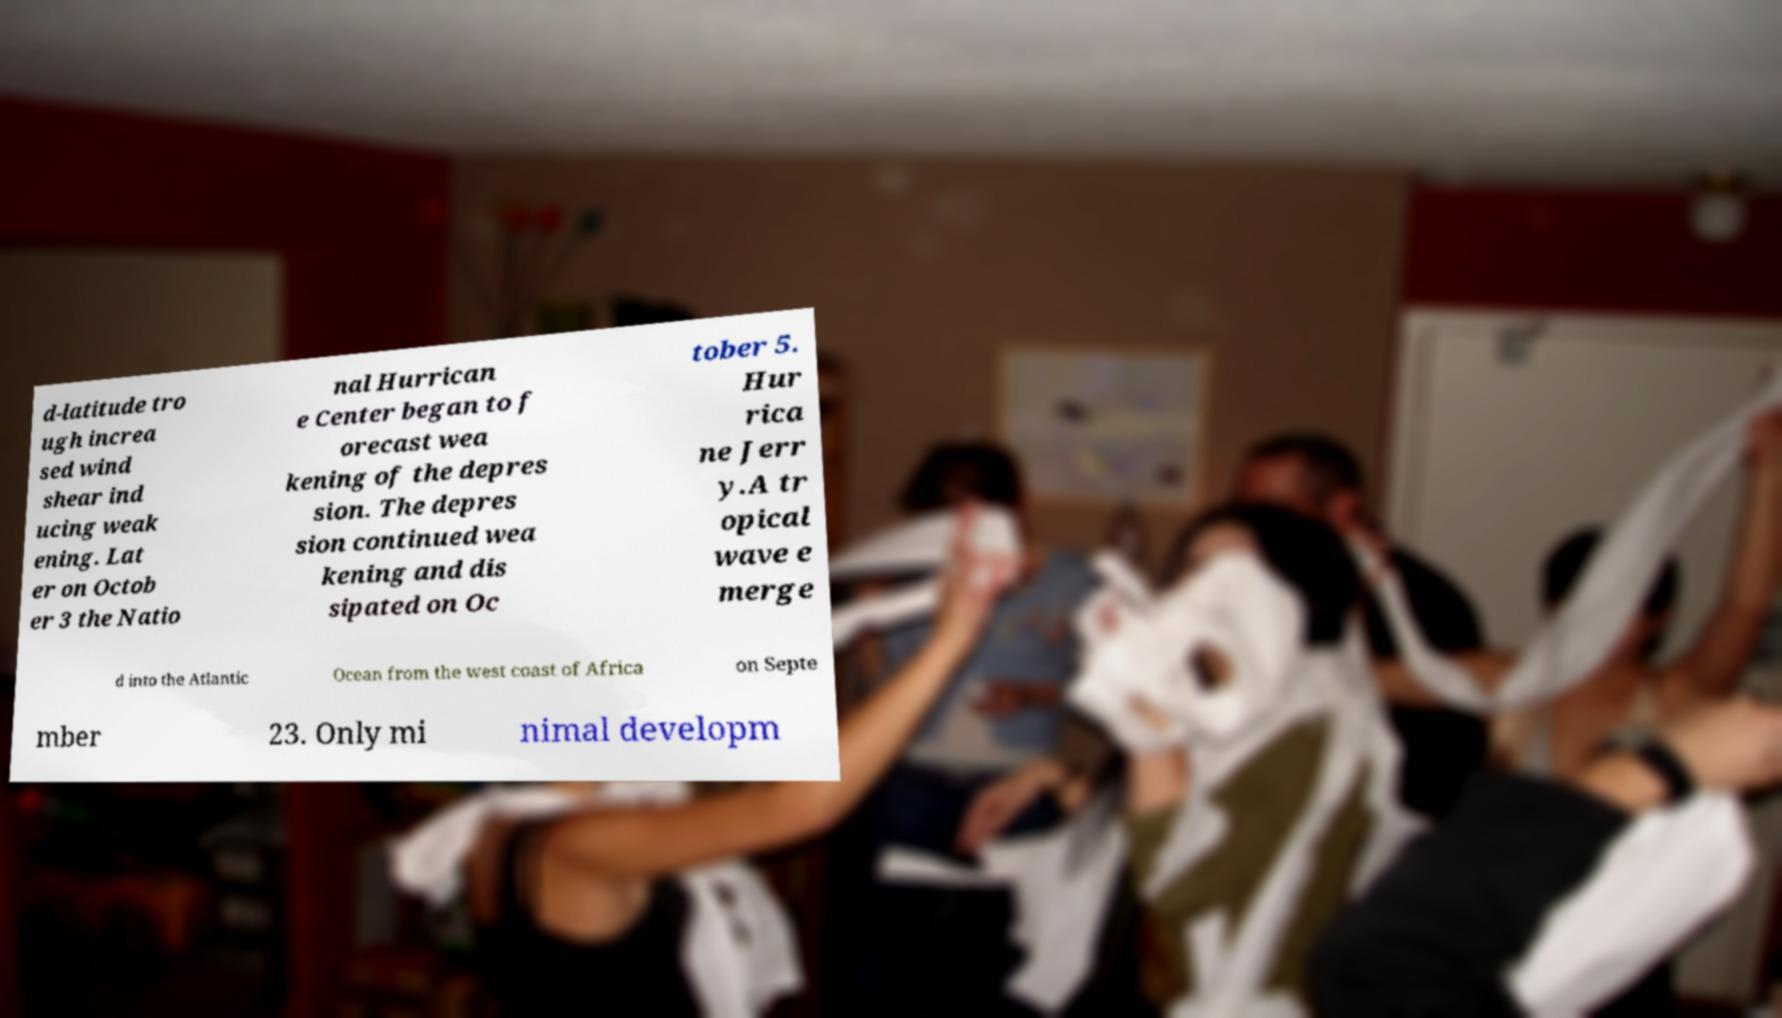For documentation purposes, I need the text within this image transcribed. Could you provide that? d-latitude tro ugh increa sed wind shear ind ucing weak ening. Lat er on Octob er 3 the Natio nal Hurrican e Center began to f orecast wea kening of the depres sion. The depres sion continued wea kening and dis sipated on Oc tober 5. Hur rica ne Jerr y.A tr opical wave e merge d into the Atlantic Ocean from the west coast of Africa on Septe mber 23. Only mi nimal developm 